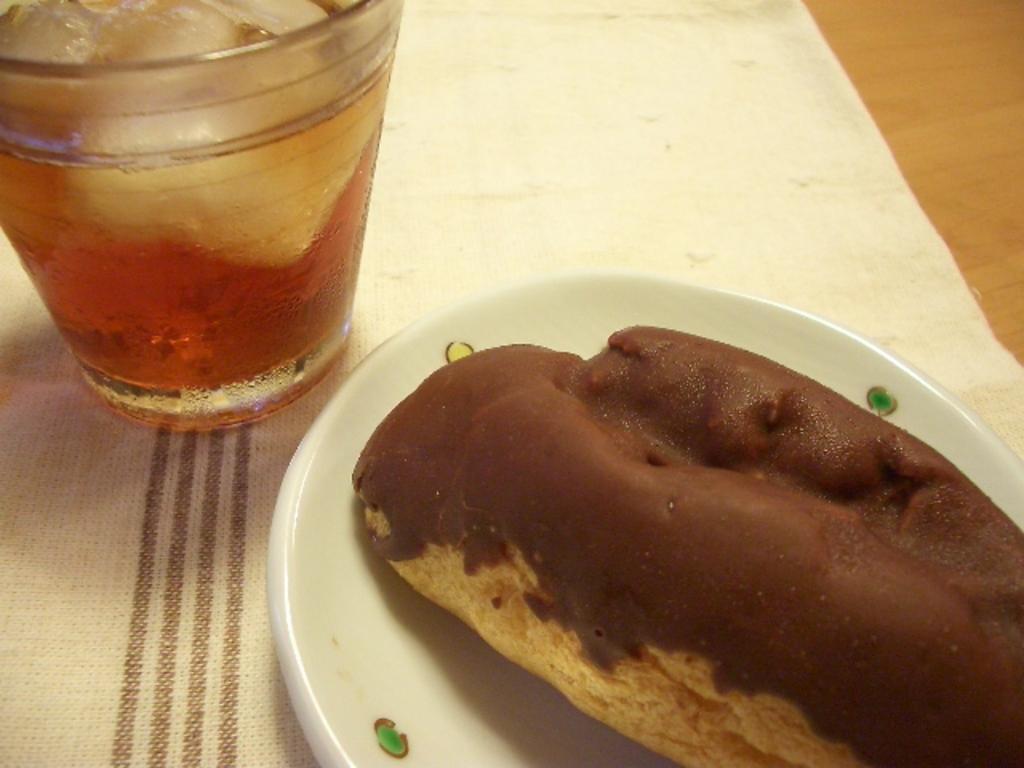Can you describe this image briefly? In this picture we can see liquid and ice cubes in a glass. We can see a food item on a plate. There is a clot visible on a wooden object. 